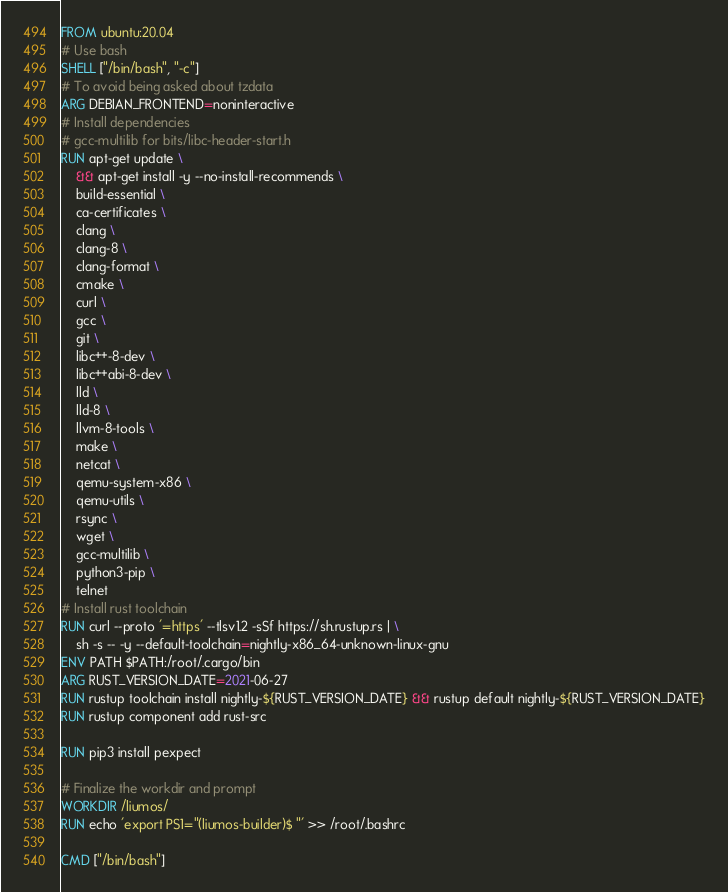Convert code to text. <code><loc_0><loc_0><loc_500><loc_500><_Dockerfile_>FROM ubuntu:20.04
# Use bash
SHELL ["/bin/bash", "-c"]
# To avoid being asked about tzdata
ARG DEBIAN_FRONTEND=noninteractive
# Install dependencies
# gcc-multilib for bits/libc-header-start.h
RUN apt-get update \
    && apt-get install -y --no-install-recommends \
	build-essential \
	ca-certificates \
	clang \
	clang-8 \
	clang-format \
	cmake \
	curl \
	gcc \
	git \
	libc++-8-dev \
	libc++abi-8-dev \
	lld \
	lld-8 \
	llvm-8-tools \
	make \
	netcat \
	qemu-system-x86 \
	qemu-utils \
	rsync \
	wget \
	gcc-multilib \
	python3-pip \
	telnet
# Install rust toolchain
RUN curl --proto '=https' --tlsv1.2 -sSf https://sh.rustup.rs | \
	sh -s -- -y --default-toolchain=nightly-x86_64-unknown-linux-gnu
ENV PATH $PATH:/root/.cargo/bin
ARG RUST_VERSION_DATE=2021-06-27
RUN rustup toolchain install nightly-${RUST_VERSION_DATE} && rustup default nightly-${RUST_VERSION_DATE}
RUN rustup component add rust-src

RUN pip3 install pexpect

# Finalize the workdir and prompt
WORKDIR /liumos/
RUN echo 'export PS1="(liumos-builder)$ "' >> /root/.bashrc

CMD ["/bin/bash"]
</code> 